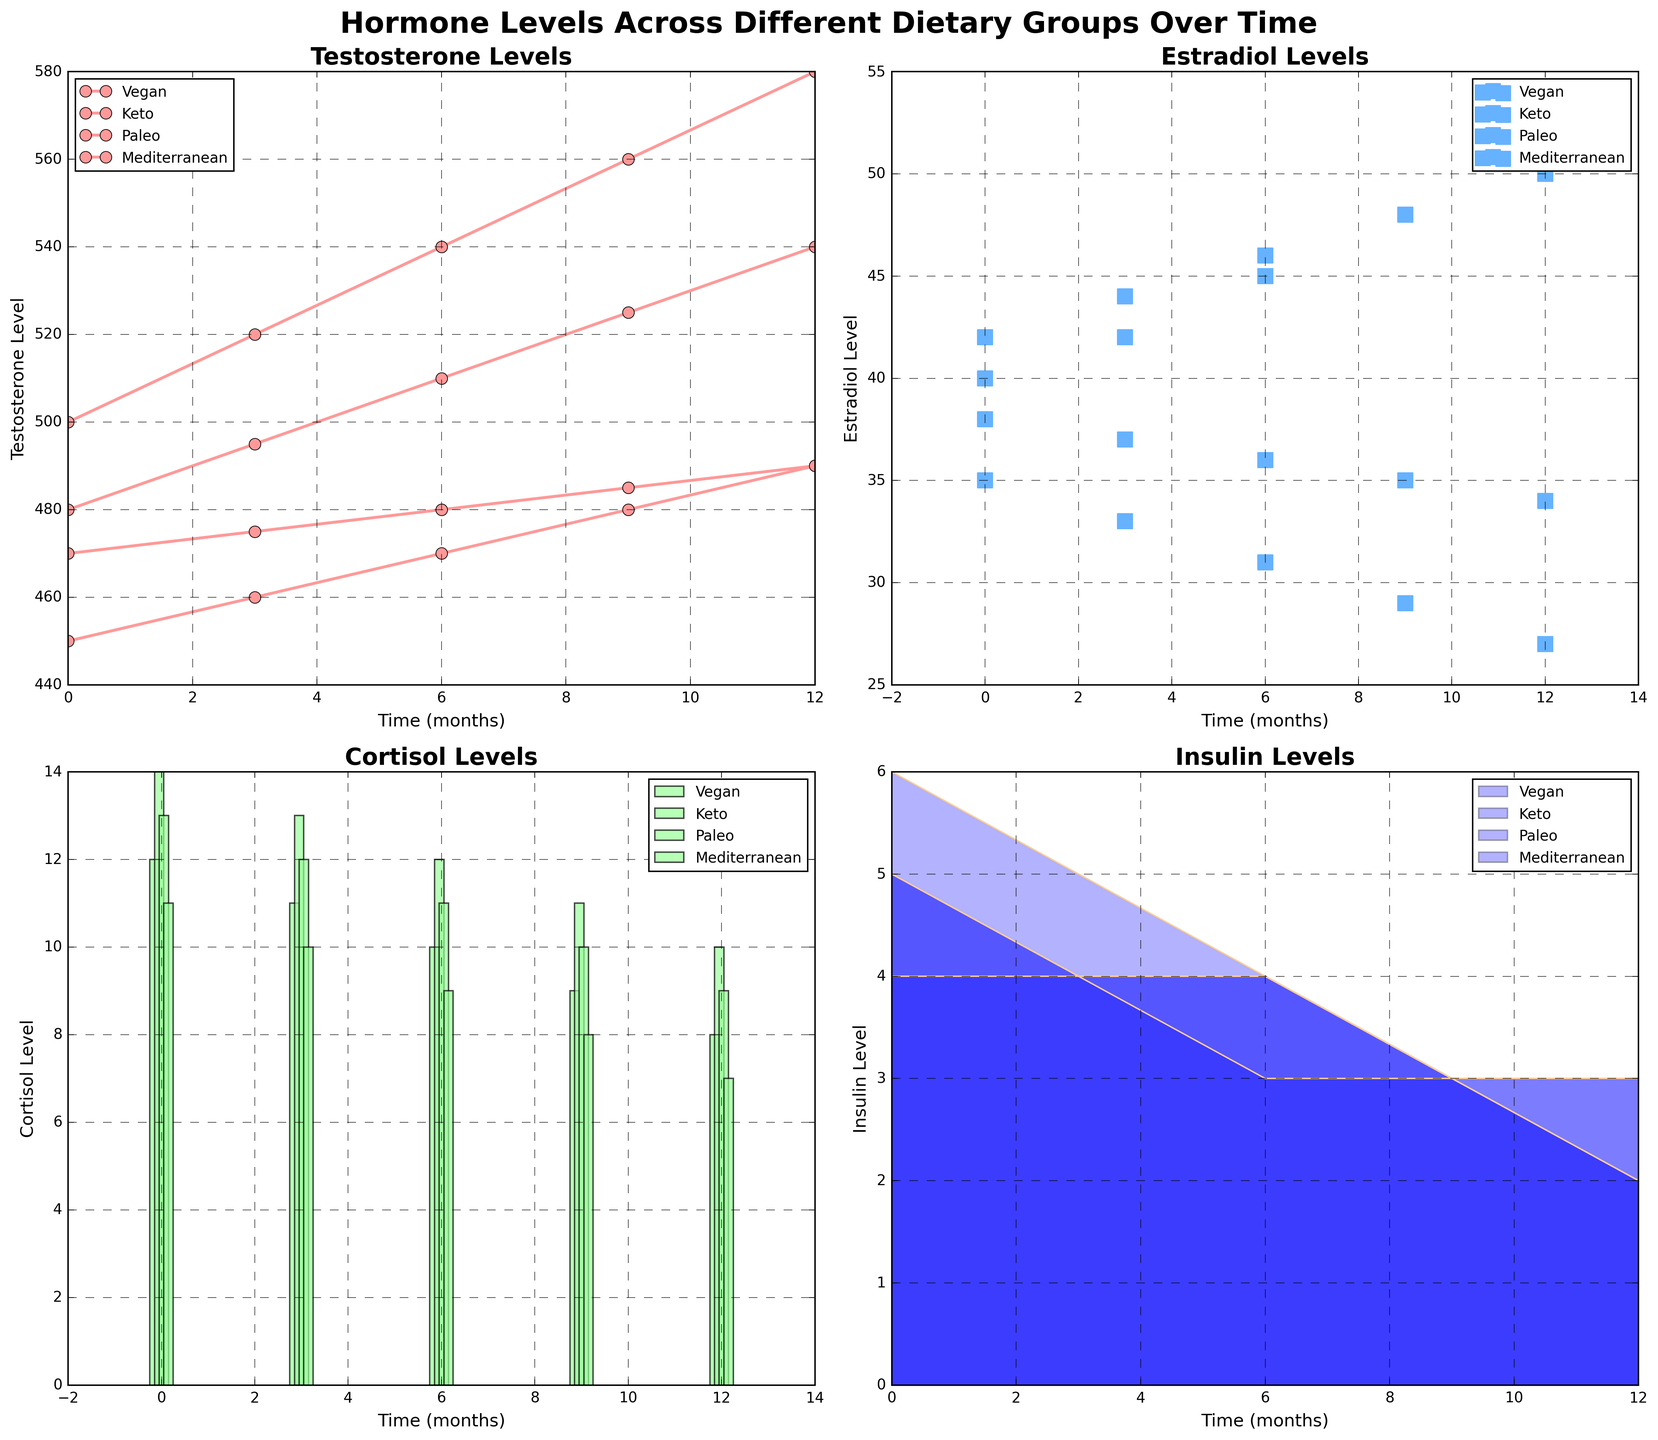Which hormone has a line plot representation in the figure? The title of the subplots and their types help identify that Testosterone levels are represented by a line plot. Each marker for the line plot corresponds to different months and dietary groups.
Answer: Testosterone How do the Estradiol levels change over time in the Paleo group? By observing the scatter plot for Estradiol levels, we see the data points for the Paleo group, which are plotted over several months. The values decrease from 38 at month 0 to 34 at month 12.
Answer: Decrease Which dietary group shows the sharpest decrease in Cortisol levels over the 12-month period? Observing the bar plot for Cortisol levels, we note the heights of the bars representing each dietary group. The Keto group shows a decrease from 14 to 10, which is the steepest reduction compared to other groups.
Answer: Keto What is the difference in Insulin levels at 12 months between the Mediterranean and Paleo diets? Checking the line plots in the area plot for Insulin levels, we see that at 12 months, the Mediterranean diet has an Insulin level of 2, and the Paleo diet has an Insulin level of 3. The difference is 3 - 2 = 1.
Answer: 1 Which diet consistently shows the highest Testosterone levels over the observed period? By following the line plot for Testosterone levels for each dietary group, the Keto diet maintains the highest levels consistently throughout the period.
Answer: Keto Compare the trend in Insulin levels for the Vegan and Keto groups. Observing the area plot for Insulin levels, we see that both the Vegan and Keto diets show a downward trend, but the decline in the Keto group is more pronounced, going down from 6 to 2, whereas the Vegan group declines more gently from 5 to 3.
Answer: Downward trends, steeper for Keto Which diet shows less fluctuation in Estradiol levels over time? By looking at the scatter plot for Estradiol, we see that the points for the Vegan diet are more stable and clustered close together, suggesting less fluctuation compared to the wider spread in other diets.
Answer: Vegan For the 6-month mark, which hormone shows the smallest variance across all diets? Comparing all the subplots at the 6-month mark, we see that Insulin levels in the area plot exhibit less variation across all dietary groups, whereas other hormones show more diverse values at this point.
Answer: Insulin 